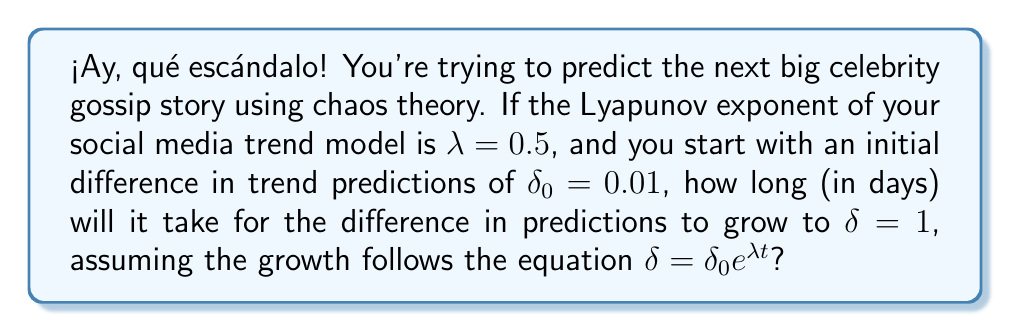What is the answer to this math problem? Let's break this down step-by-step, mi querido lector:

1) We're using the equation for chaotic growth: $\delta = \delta_0 e^{\lambda t}$

2) We know:
   - $\lambda = 0.5$ (Lyapunov exponent)
   - $\delta_0 = 0.01$ (initial difference)
   - $\delta = 1$ (final difference)

3) Let's substitute these into our equation:
   $1 = 0.01 e^{0.5t}$

4) Now, let's solve for $t$:
   
   Divide both sides by 0.01:
   $100 = e^{0.5t}$

   Take the natural log of both sides:
   $\ln(100) = \ln(e^{0.5t})$

   Simplify the right side:
   $\ln(100) = 0.5t$

   Divide both sides by 0.5:
   $\frac{\ln(100)}{0.5} = t$

5) Calculate the result:
   $t = \frac{\ln(100)}{0.5} \approx 9.21$ days

¡Escándalo! It will take about 9.21 days for the difference in trend predictions to grow from 0.01 to 1.
Answer: 9.21 days 